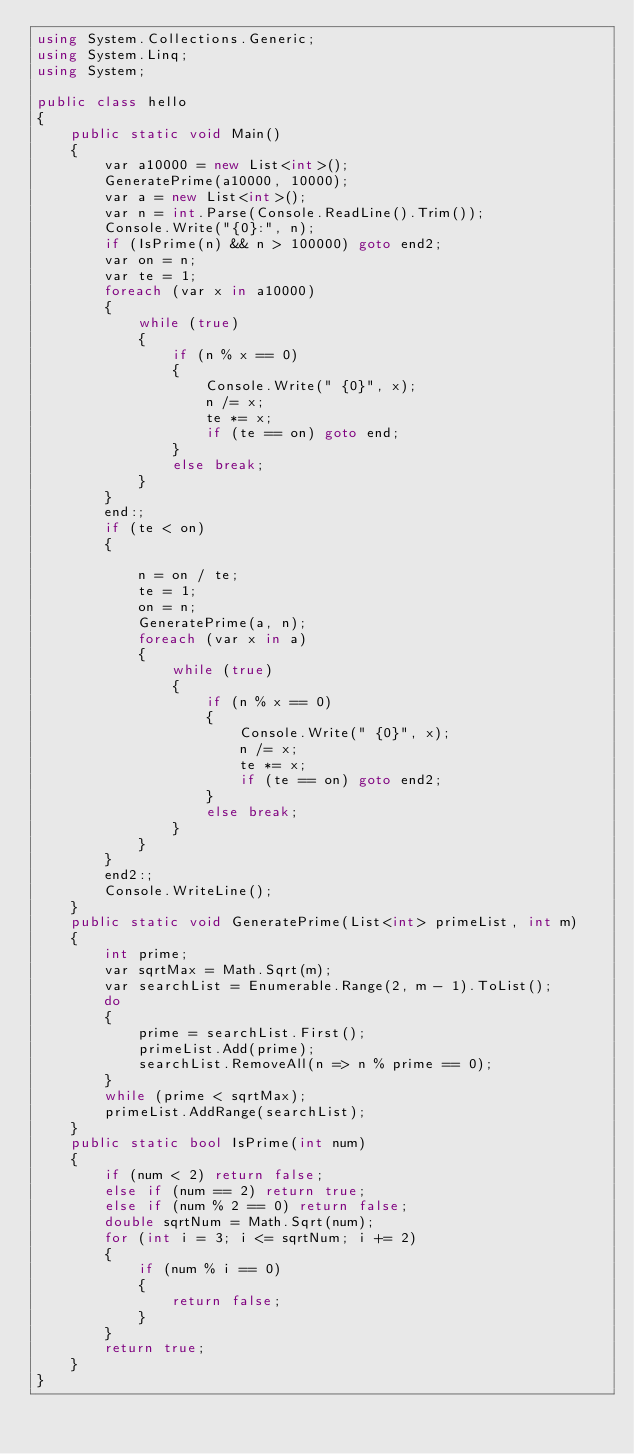<code> <loc_0><loc_0><loc_500><loc_500><_C#_>using System.Collections.Generic;
using System.Linq;
using System;

public class hello
{
    public static void Main()
    {
        var a10000 = new List<int>();
        GeneratePrime(a10000, 10000);
        var a = new List<int>();
        var n = int.Parse(Console.ReadLine().Trim());
        Console.Write("{0}:", n);
        if (IsPrime(n) && n > 100000) goto end2;
        var on = n;
        var te = 1;
        foreach (var x in a10000)
        {
            while (true)
            {
                if (n % x == 0)
                {
                    Console.Write(" {0}", x);
                    n /= x;
                    te *= x;
                    if (te == on) goto end;
                }
                else break;
            }
        }
        end:;
        if (te < on)
        {

            n = on / te;
            te = 1;
            on = n;
            GeneratePrime(a, n);
            foreach (var x in a)
            {
                while (true)
                {
                    if (n % x == 0)
                    {
                        Console.Write(" {0}", x);
                        n /= x;
                        te *= x;
                        if (te == on) goto end2;
                    }
                    else break;
                }
            }
        }
        end2:;
        Console.WriteLine();
    }
    public static void GeneratePrime(List<int> primeList, int m)
    {
        int prime;
        var sqrtMax = Math.Sqrt(m);
        var searchList = Enumerable.Range(2, m - 1).ToList();
        do
        {
            prime = searchList.First();
            primeList.Add(prime);
            searchList.RemoveAll(n => n % prime == 0);
        }
        while (prime < sqrtMax);
        primeList.AddRange(searchList);
    }
    public static bool IsPrime(int num)
    {
        if (num < 2) return false;
        else if (num == 2) return true;
        else if (num % 2 == 0) return false; 
        double sqrtNum = Math.Sqrt(num);
        for (int i = 3; i <= sqrtNum; i += 2)
        {
            if (num % i == 0)
            {
                return false;
            }
        }
        return true;
    }
}</code> 